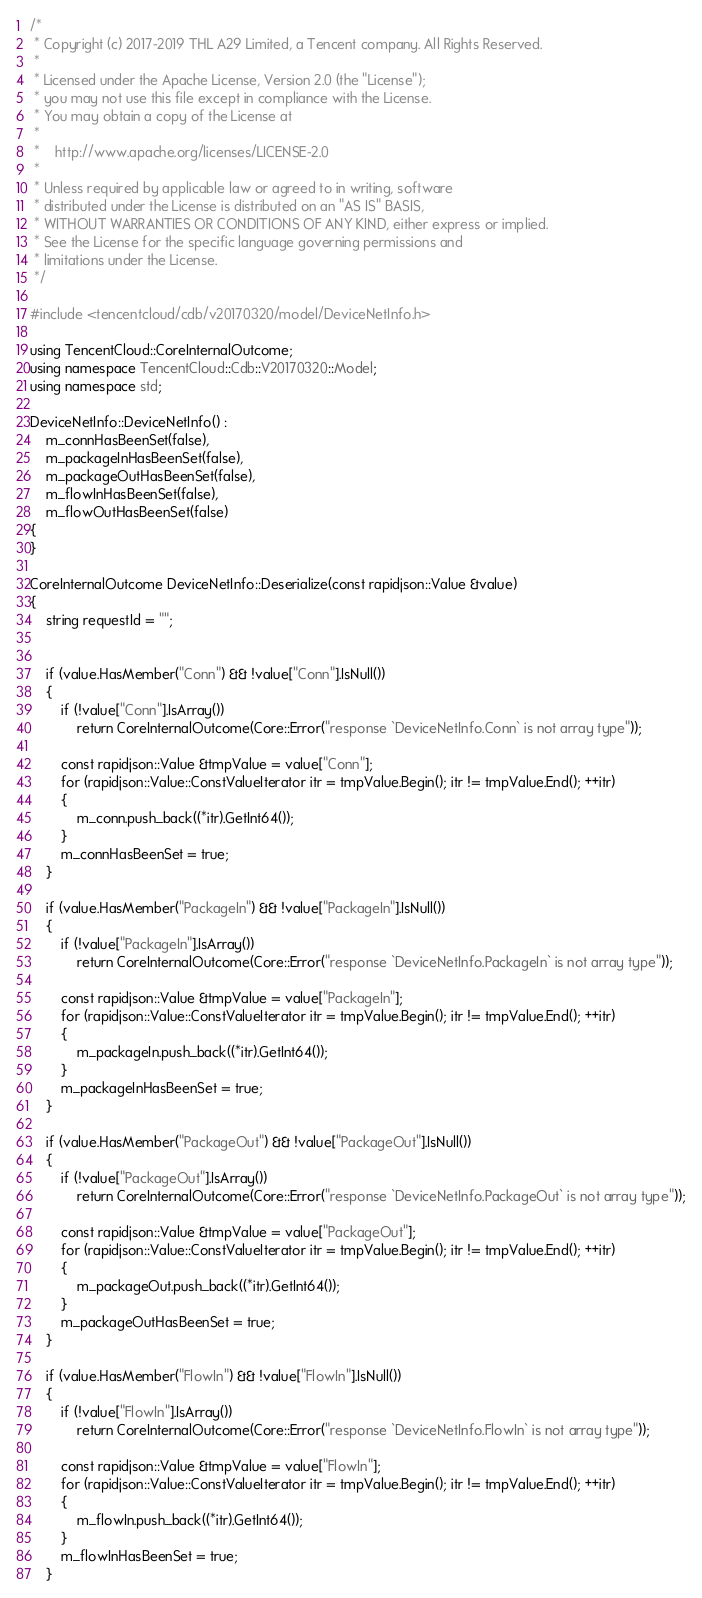<code> <loc_0><loc_0><loc_500><loc_500><_C++_>/*
 * Copyright (c) 2017-2019 THL A29 Limited, a Tencent company. All Rights Reserved.
 *
 * Licensed under the Apache License, Version 2.0 (the "License");
 * you may not use this file except in compliance with the License.
 * You may obtain a copy of the License at
 *
 *    http://www.apache.org/licenses/LICENSE-2.0
 *
 * Unless required by applicable law or agreed to in writing, software
 * distributed under the License is distributed on an "AS IS" BASIS,
 * WITHOUT WARRANTIES OR CONDITIONS OF ANY KIND, either express or implied.
 * See the License for the specific language governing permissions and
 * limitations under the License.
 */

#include <tencentcloud/cdb/v20170320/model/DeviceNetInfo.h>

using TencentCloud::CoreInternalOutcome;
using namespace TencentCloud::Cdb::V20170320::Model;
using namespace std;

DeviceNetInfo::DeviceNetInfo() :
    m_connHasBeenSet(false),
    m_packageInHasBeenSet(false),
    m_packageOutHasBeenSet(false),
    m_flowInHasBeenSet(false),
    m_flowOutHasBeenSet(false)
{
}

CoreInternalOutcome DeviceNetInfo::Deserialize(const rapidjson::Value &value)
{
    string requestId = "";


    if (value.HasMember("Conn") && !value["Conn"].IsNull())
    {
        if (!value["Conn"].IsArray())
            return CoreInternalOutcome(Core::Error("response `DeviceNetInfo.Conn` is not array type"));

        const rapidjson::Value &tmpValue = value["Conn"];
        for (rapidjson::Value::ConstValueIterator itr = tmpValue.Begin(); itr != tmpValue.End(); ++itr)
        {
            m_conn.push_back((*itr).GetInt64());
        }
        m_connHasBeenSet = true;
    }

    if (value.HasMember("PackageIn") && !value["PackageIn"].IsNull())
    {
        if (!value["PackageIn"].IsArray())
            return CoreInternalOutcome(Core::Error("response `DeviceNetInfo.PackageIn` is not array type"));

        const rapidjson::Value &tmpValue = value["PackageIn"];
        for (rapidjson::Value::ConstValueIterator itr = tmpValue.Begin(); itr != tmpValue.End(); ++itr)
        {
            m_packageIn.push_back((*itr).GetInt64());
        }
        m_packageInHasBeenSet = true;
    }

    if (value.HasMember("PackageOut") && !value["PackageOut"].IsNull())
    {
        if (!value["PackageOut"].IsArray())
            return CoreInternalOutcome(Core::Error("response `DeviceNetInfo.PackageOut` is not array type"));

        const rapidjson::Value &tmpValue = value["PackageOut"];
        for (rapidjson::Value::ConstValueIterator itr = tmpValue.Begin(); itr != tmpValue.End(); ++itr)
        {
            m_packageOut.push_back((*itr).GetInt64());
        }
        m_packageOutHasBeenSet = true;
    }

    if (value.HasMember("FlowIn") && !value["FlowIn"].IsNull())
    {
        if (!value["FlowIn"].IsArray())
            return CoreInternalOutcome(Core::Error("response `DeviceNetInfo.FlowIn` is not array type"));

        const rapidjson::Value &tmpValue = value["FlowIn"];
        for (rapidjson::Value::ConstValueIterator itr = tmpValue.Begin(); itr != tmpValue.End(); ++itr)
        {
            m_flowIn.push_back((*itr).GetInt64());
        }
        m_flowInHasBeenSet = true;
    }
</code> 